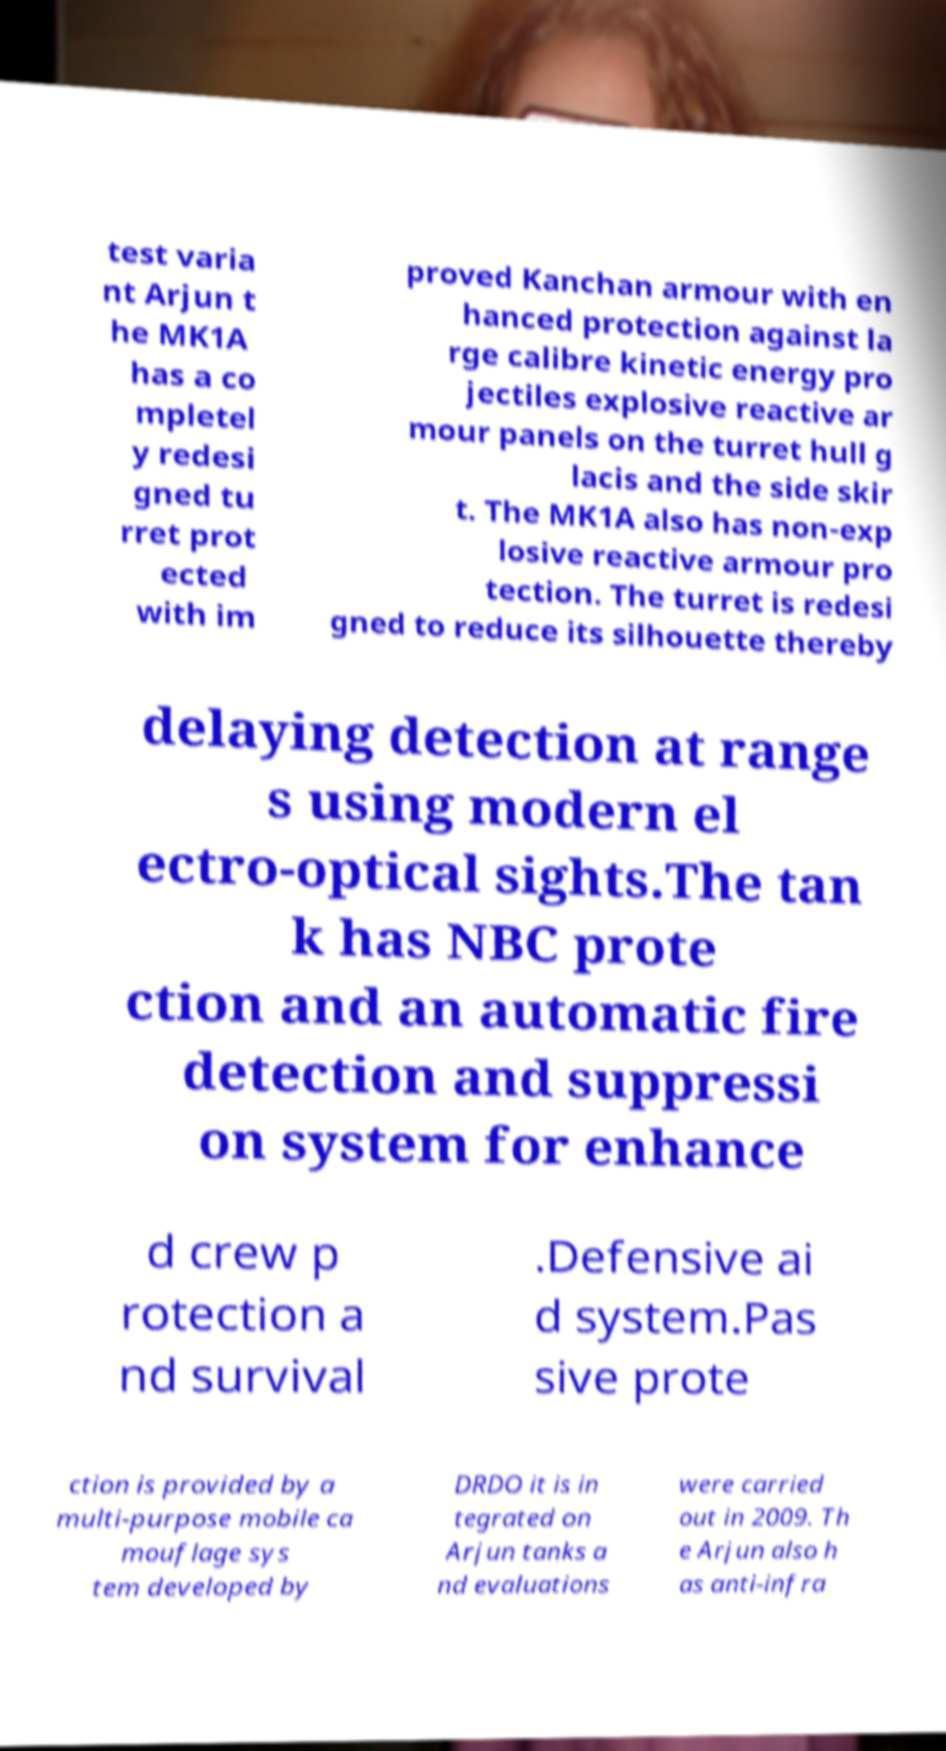Can you accurately transcribe the text from the provided image for me? test varia nt Arjun t he MK1A has a co mpletel y redesi gned tu rret prot ected with im proved Kanchan armour with en hanced protection against la rge calibre kinetic energy pro jectiles explosive reactive ar mour panels on the turret hull g lacis and the side skir t. The MK1A also has non-exp losive reactive armour pro tection. The turret is redesi gned to reduce its silhouette thereby delaying detection at range s using modern el ectro-optical sights.The tan k has NBC prote ction and an automatic fire detection and suppressi on system for enhance d crew p rotection a nd survival .Defensive ai d system.Pas sive prote ction is provided by a multi-purpose mobile ca mouflage sys tem developed by DRDO it is in tegrated on Arjun tanks a nd evaluations were carried out in 2009. Th e Arjun also h as anti-infra 